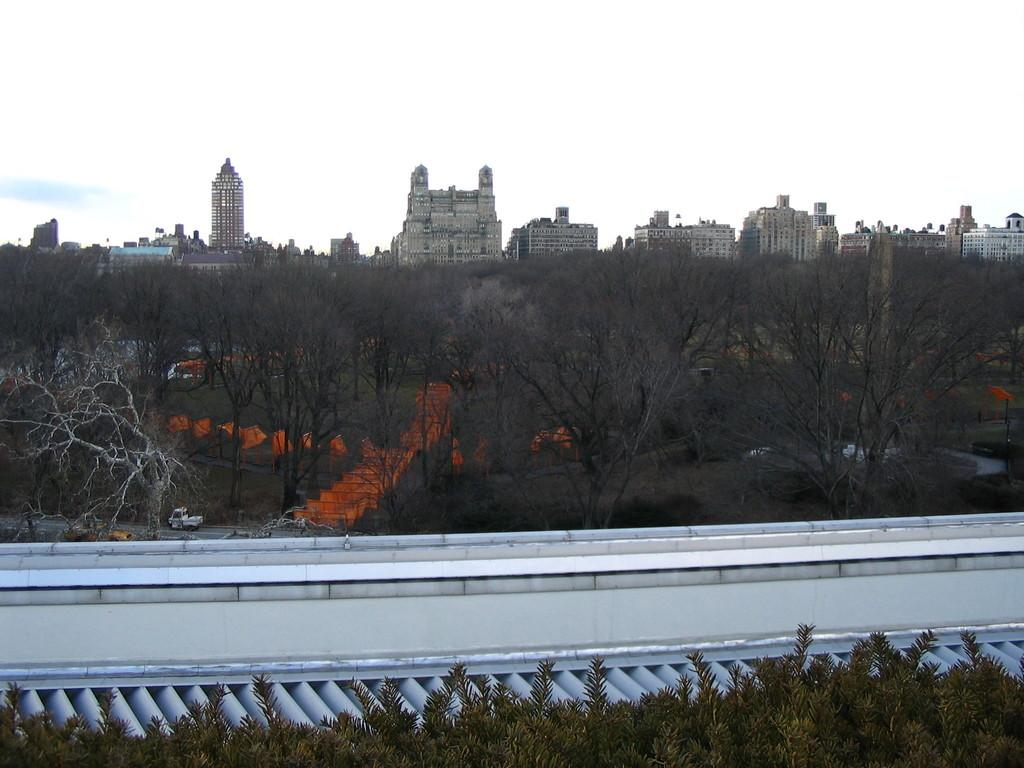What type of vegetation is present in the front of the image? There are leaves in the front of the image. What structure is located in the center of the image? There is a wall in the center of the image. What can be seen in the background of the image? There are trees, buildings, and cars in the background of the image. What is the condition of the sky in the image? The sky is cloudy in the image. What arithmetic problem is being solved on the wall in the image? There is no arithmetic problem visible on the wall in the image. What type of vegetation is growing between the trees in the background of the image? The provided facts do not mention any bushes or grass growing between the trees in the background of the image. 